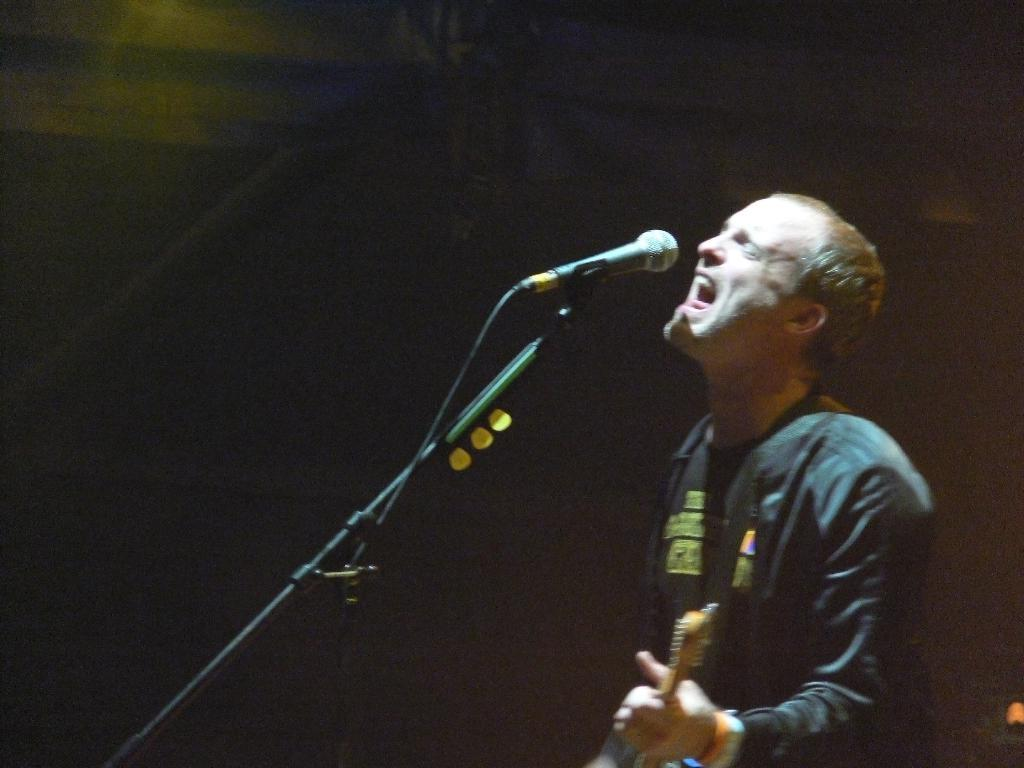What is the main subject of the image? The main subject of the image is a man. What is the man holding in the image? The man is holding a musical instrument. What object is in front of the man? The man is in front of a microphone. What type of error can be seen in the image? There is no error present in the image. What act is the man performing in the image? The provided facts do not specify any particular act the man is performing; he is simply holding a musical instrument and standing in front of a microphone. 